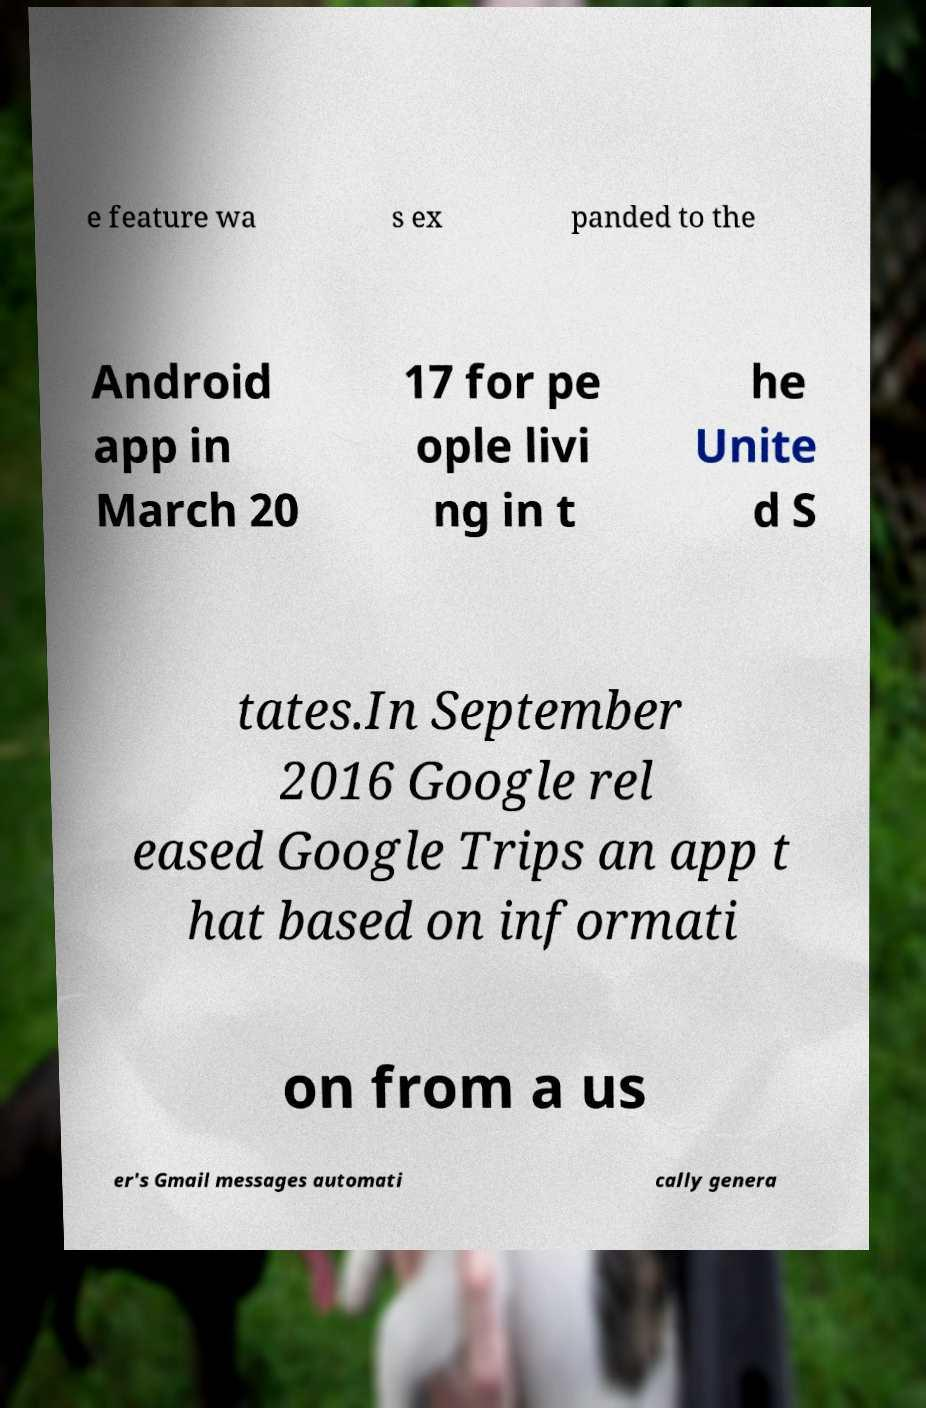Can you accurately transcribe the text from the provided image for me? e feature wa s ex panded to the Android app in March 20 17 for pe ople livi ng in t he Unite d S tates.In September 2016 Google rel eased Google Trips an app t hat based on informati on from a us er's Gmail messages automati cally genera 